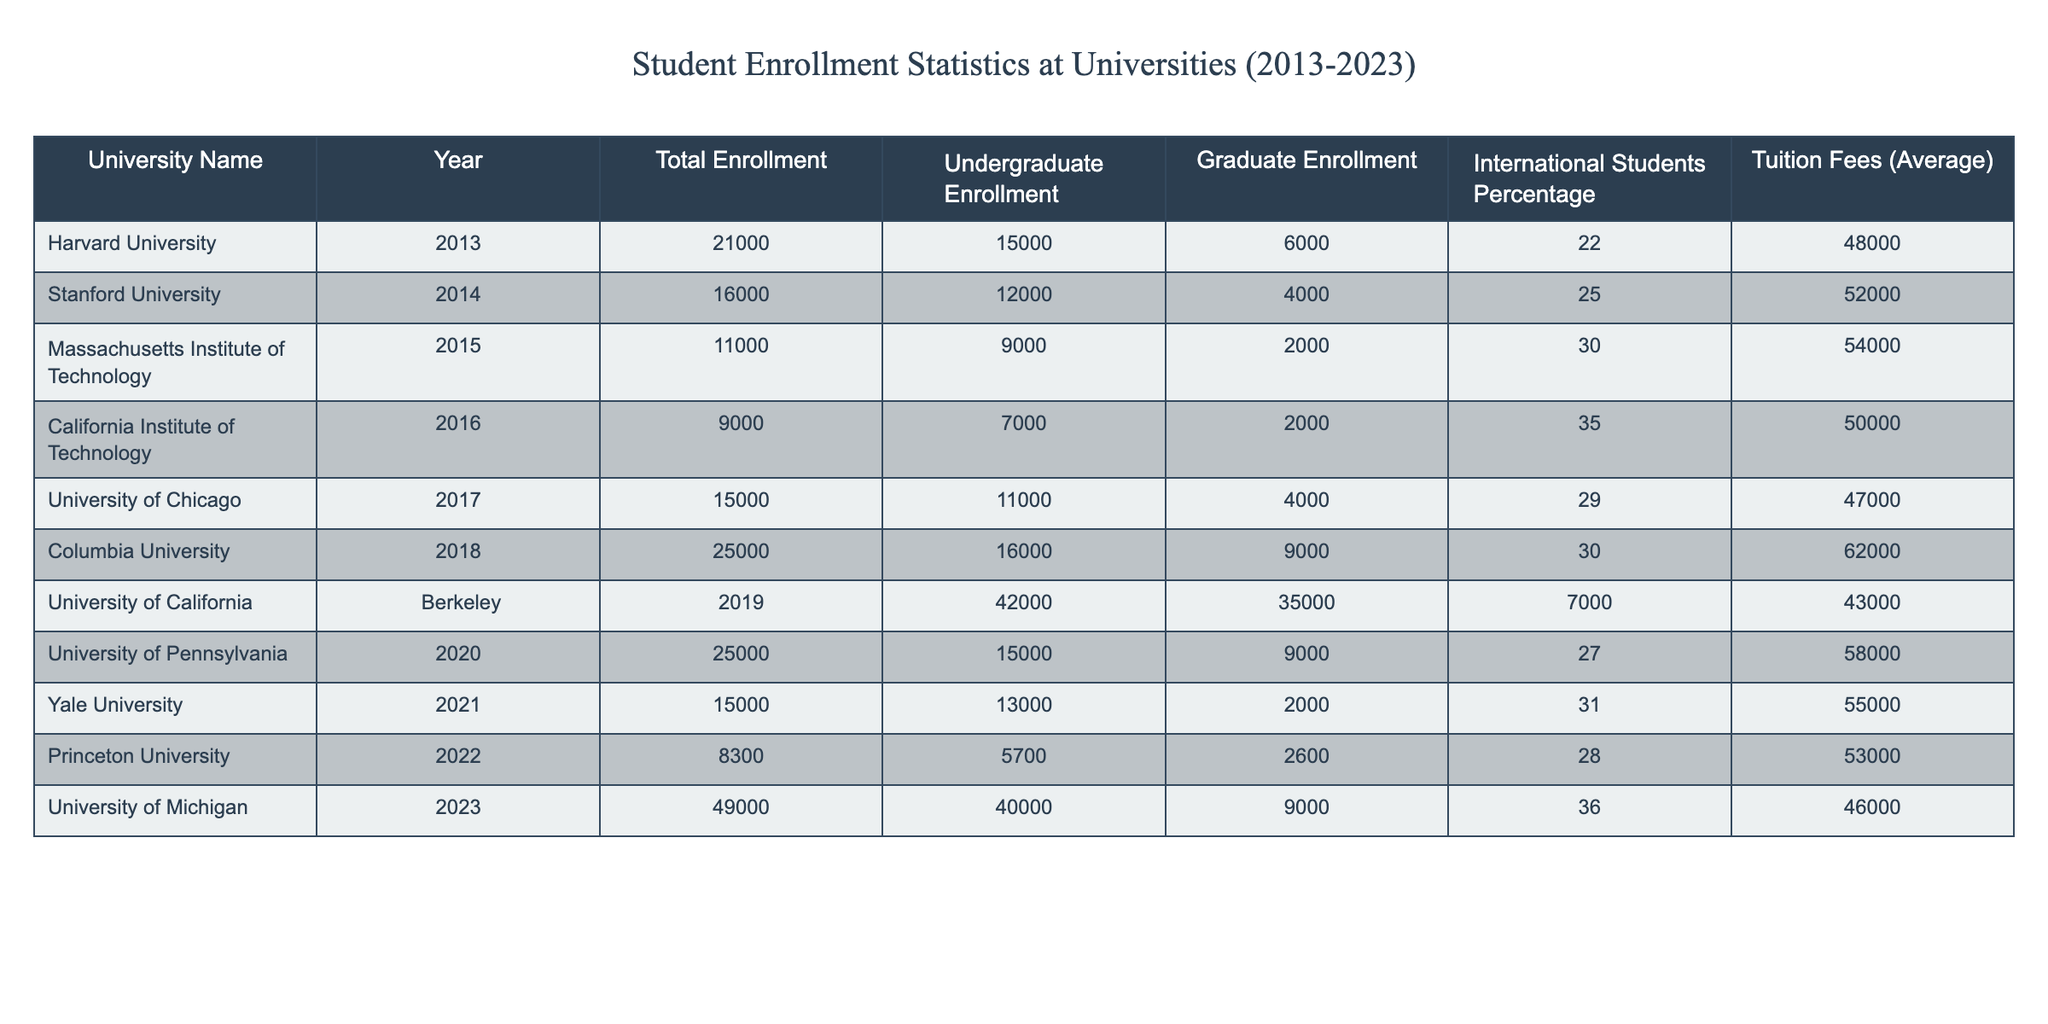What was the total enrollment number for Columbia University? Directly look under the "University Name" column for Columbia University and refer to the "Total Enrollment" column, which shows 25000.
Answer: 25000 What is the average tuition fee for the universities listed between 2013 and 2023? To find the average tuition fee, sum the average fees provided: 48000 + 52000 + 54000 + 50000 + 47000 + 62000 + 43000 + 58000 + 55000 + 53000 =  472000. Then divide by the number of universities, which is 10. Therefore, 472000/10 = 47200.
Answer: 47200 Did Harvard University have a higher undergraduate enrollment than Stanford University? Comparing the "Undergraduate Enrollment" for Harvard University (15000) and Stanford University (12000), I see that Harvard's number is greater.
Answer: Yes In which year did University of California, Berkeley have the highest total enrollment? Referring to the table, I see that University of California, Berkeley has total enrollment recorded in 2019 as 42000. This is the highest when compared with other years.
Answer: 2019 What percentage of total enrollments at the University of Michigan were international students? To find the percentage of international students at the University of Michigan, check the "International Students Percentage" column for 2023, which shows 36%.
Answer: 36% What is the total enrollment of graduate students across all universities in 2021? Checking the "Graduate Enrollment" column for 2021, the only university provided is Yale University, which shows 2000 graduate students. As no other universities are listed for that year, the total is just 2000.
Answer: 2000 Which university had the lowest tuition fee, and what was the amount? Looking down the "Tuition Fees (Average)" column, I see that the lowest value is 43000 associated with University of California, Berkeley.
Answer: 43000 What was the difference in the number of total enrollments between Massachusetts Institute of Technology and Princeton University? The total enrollment for Massachusetts Institute of Technology is 11000, while for Princeton University, it is 8300. The difference is calculated as 11000 - 8300 = 2700.
Answer: 2700 